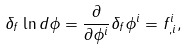Convert formula to latex. <formula><loc_0><loc_0><loc_500><loc_500>\delta _ { f } \ln d \phi = \frac { \partial } { \partial \phi ^ { i } } \delta _ { f } \phi ^ { i } = f ^ { i } _ { , i } ,</formula> 